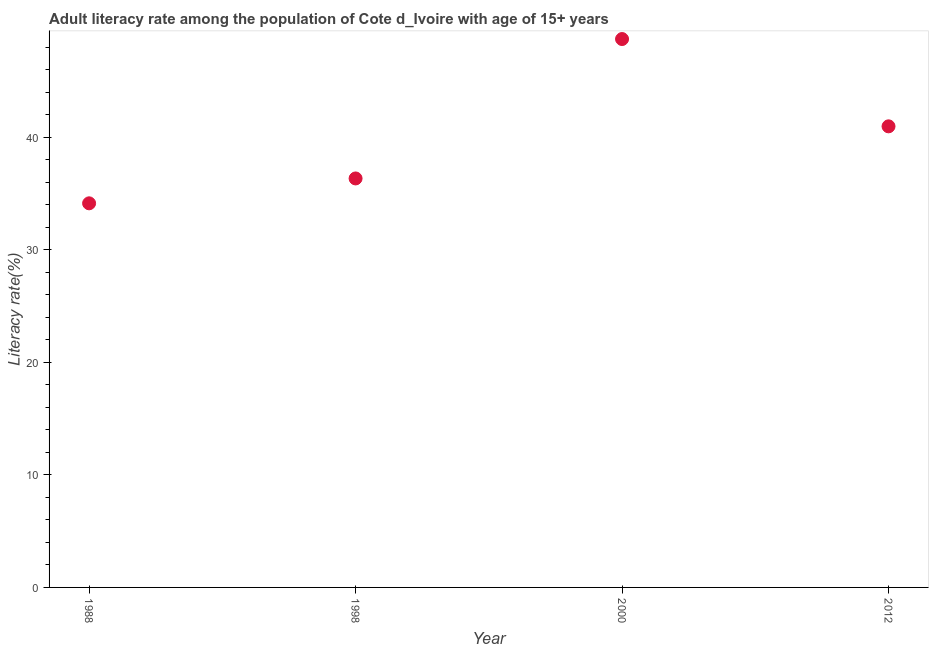What is the adult literacy rate in 2000?
Give a very brief answer. 48.74. Across all years, what is the maximum adult literacy rate?
Your answer should be very brief. 48.74. Across all years, what is the minimum adult literacy rate?
Your answer should be compact. 34.14. What is the sum of the adult literacy rate?
Your answer should be very brief. 160.21. What is the difference between the adult literacy rate in 2000 and 2012?
Offer a very short reply. 7.76. What is the average adult literacy rate per year?
Provide a succinct answer. 40.05. What is the median adult literacy rate?
Offer a terse response. 38.67. What is the ratio of the adult literacy rate in 1988 to that in 2012?
Offer a very short reply. 0.83. Is the adult literacy rate in 1998 less than that in 2012?
Provide a short and direct response. Yes. Is the difference between the adult literacy rate in 1998 and 2012 greater than the difference between any two years?
Your response must be concise. No. What is the difference between the highest and the second highest adult literacy rate?
Keep it short and to the point. 7.76. Is the sum of the adult literacy rate in 2000 and 2012 greater than the maximum adult literacy rate across all years?
Give a very brief answer. Yes. What is the difference between the highest and the lowest adult literacy rate?
Your response must be concise. 14.6. Does the adult literacy rate monotonically increase over the years?
Offer a terse response. No. How many dotlines are there?
Provide a short and direct response. 1. How many years are there in the graph?
Your answer should be compact. 4. What is the difference between two consecutive major ticks on the Y-axis?
Offer a very short reply. 10. Does the graph contain grids?
Make the answer very short. No. What is the title of the graph?
Ensure brevity in your answer.  Adult literacy rate among the population of Cote d_Ivoire with age of 15+ years. What is the label or title of the Y-axis?
Offer a terse response. Literacy rate(%). What is the Literacy rate(%) in 1988?
Keep it short and to the point. 34.14. What is the Literacy rate(%) in 1998?
Give a very brief answer. 36.35. What is the Literacy rate(%) in 2000?
Give a very brief answer. 48.74. What is the Literacy rate(%) in 2012?
Provide a succinct answer. 40.98. What is the difference between the Literacy rate(%) in 1988 and 1998?
Provide a succinct answer. -2.21. What is the difference between the Literacy rate(%) in 1988 and 2000?
Provide a succinct answer. -14.6. What is the difference between the Literacy rate(%) in 1988 and 2012?
Ensure brevity in your answer.  -6.84. What is the difference between the Literacy rate(%) in 1998 and 2000?
Ensure brevity in your answer.  -12.39. What is the difference between the Literacy rate(%) in 1998 and 2012?
Your answer should be very brief. -4.63. What is the difference between the Literacy rate(%) in 2000 and 2012?
Ensure brevity in your answer.  7.76. What is the ratio of the Literacy rate(%) in 1988 to that in 1998?
Offer a terse response. 0.94. What is the ratio of the Literacy rate(%) in 1988 to that in 2012?
Keep it short and to the point. 0.83. What is the ratio of the Literacy rate(%) in 1998 to that in 2000?
Make the answer very short. 0.75. What is the ratio of the Literacy rate(%) in 1998 to that in 2012?
Your answer should be very brief. 0.89. What is the ratio of the Literacy rate(%) in 2000 to that in 2012?
Make the answer very short. 1.19. 